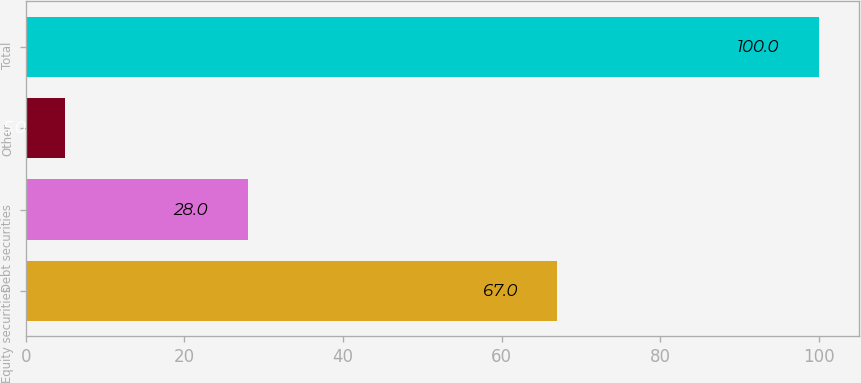Convert chart. <chart><loc_0><loc_0><loc_500><loc_500><bar_chart><fcel>Equity securities<fcel>Debt securities<fcel>Other<fcel>Total<nl><fcel>67<fcel>28<fcel>5<fcel>100<nl></chart> 